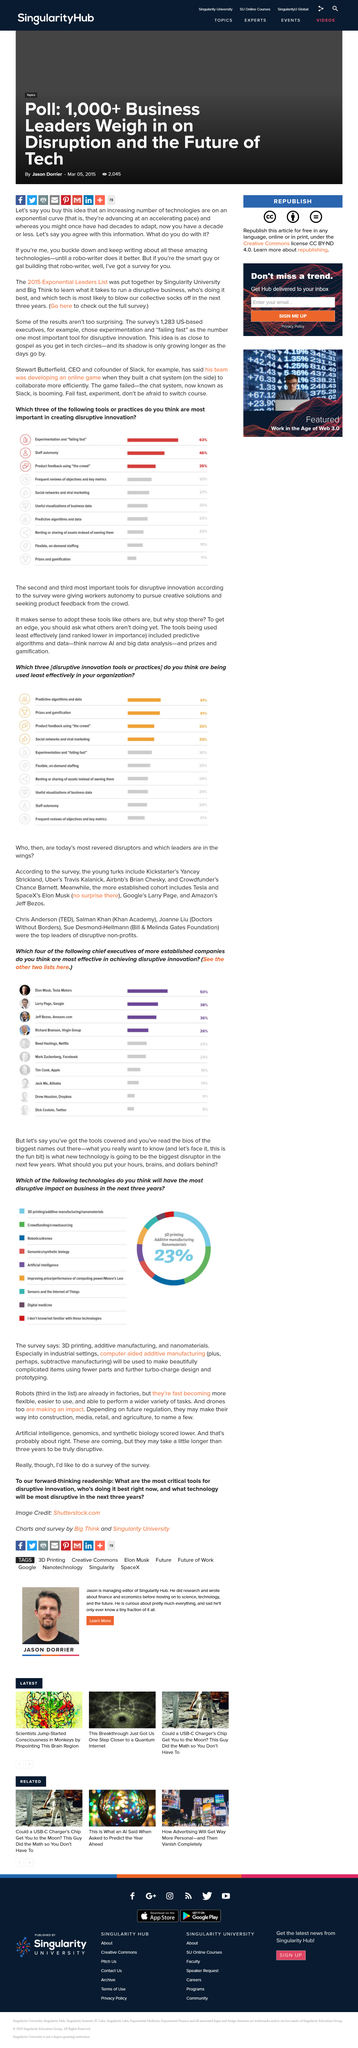Outline some significant characteristics in this image. Staff autonomy is a key principle that is represented by the icon. According to the survey, the second most important tool for disruptive innovation is granting workers autonomy to pursue creative solutions. According to the survey, seeking product feedback from the crowd is the third most important tool for disruptive innovation. 